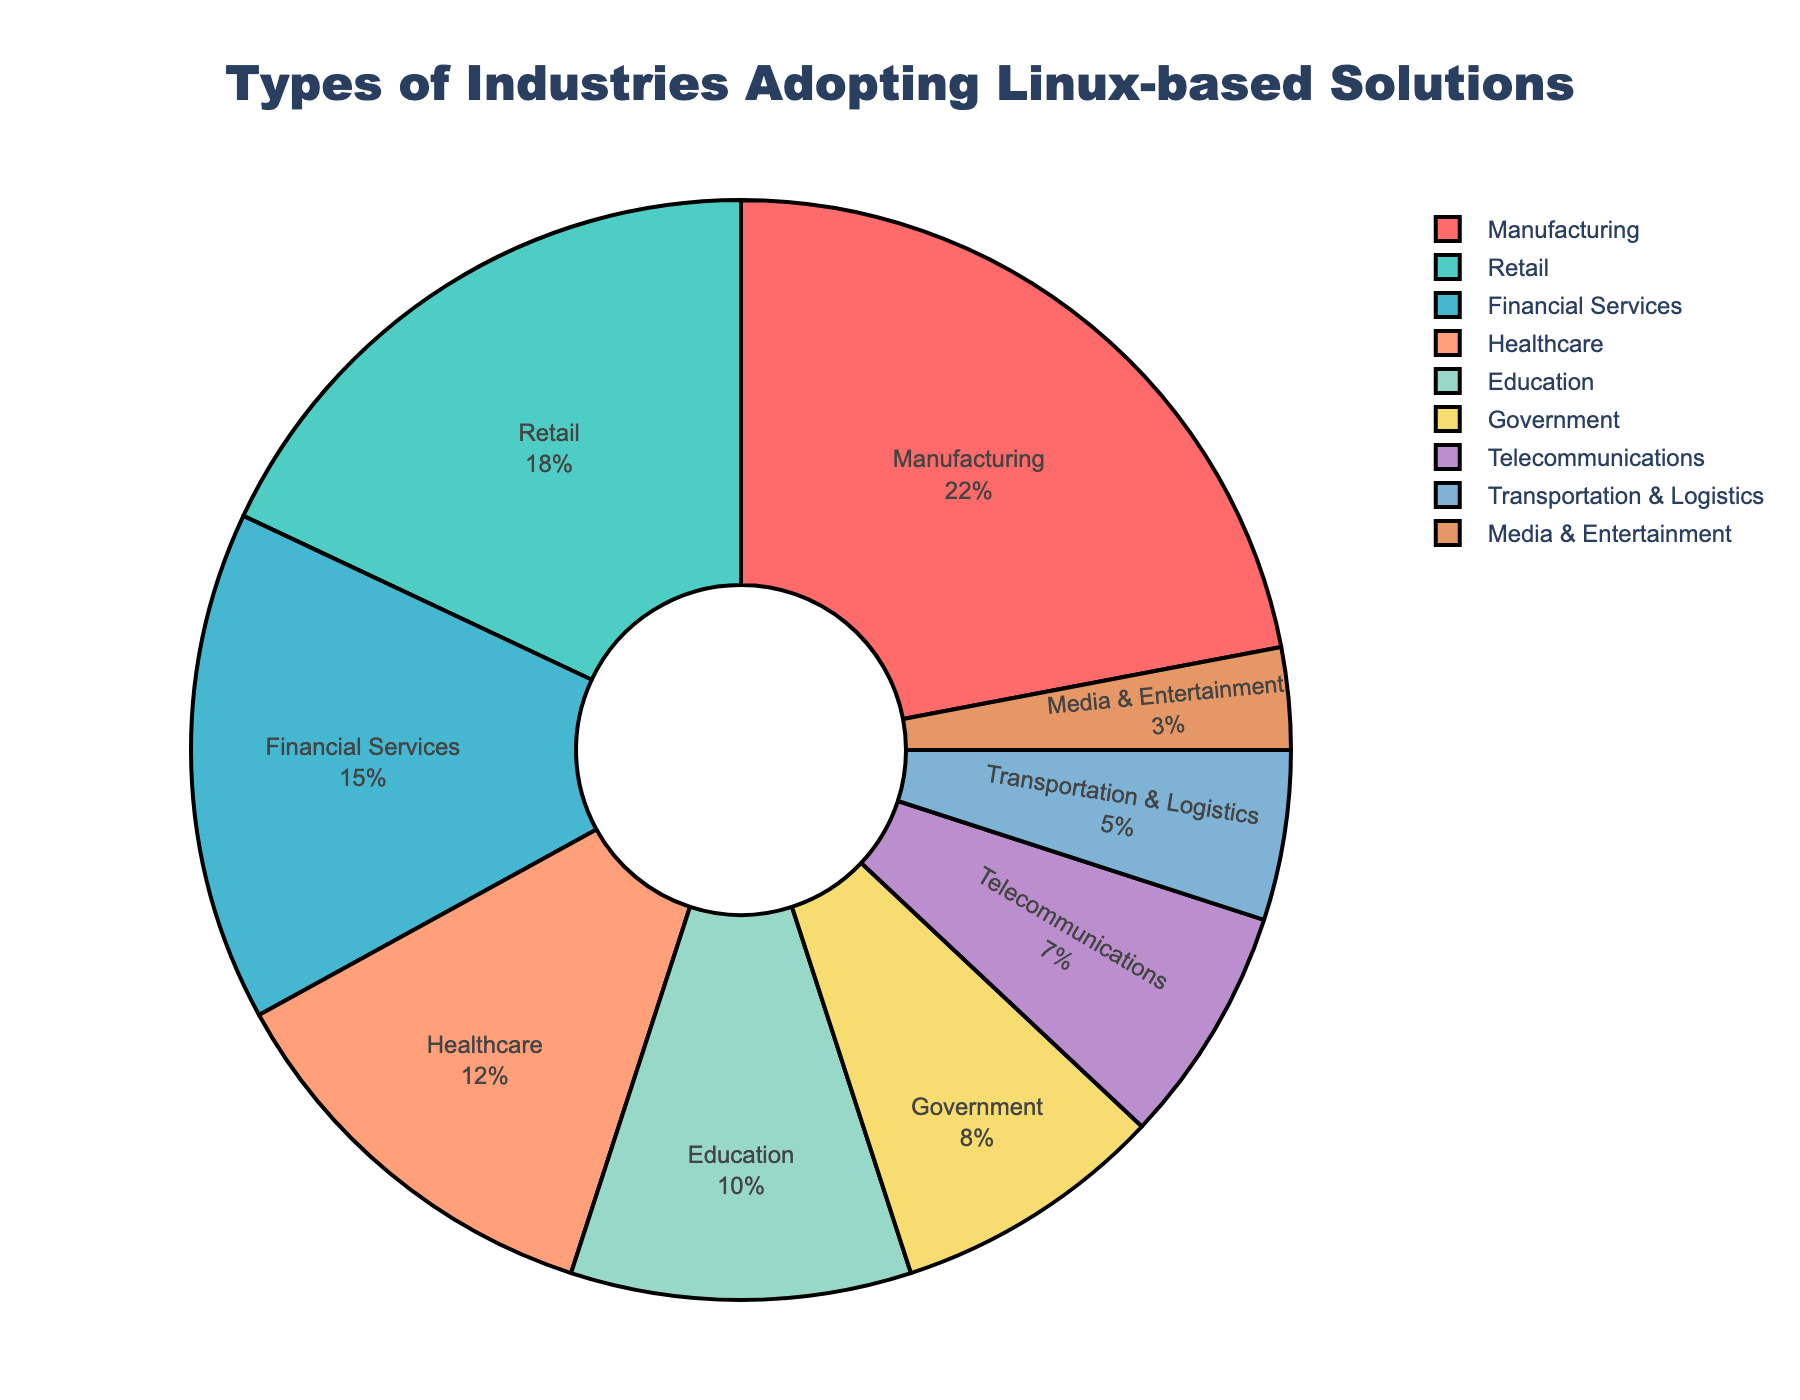What's the highest percentage of industries adopting Linux-based solutions? Look at the pie chart and identify the industry with the largest section and highest percentage value. The largest section and the highest percentage is attributed to Manufacturing, which comprises 22%.
Answer: Manufacturing (22%) Which industry has the smallest adoption rate of Linux-based solutions? Observe the smallest slice of the pie chart and check its corresponding label. The smallest slice is colored in a light brown hue and labeled Media & Entertainment with 3%.
Answer: Media & Entertainment (3%) How much more percentage does the Manufacturing sector have compared to the Telecommunications sector? Note the percentages of both sectors: Manufacturing is 22% and Telecommunications is 7%. Subtract the latter from the former: 22% - 7% = 15%.
Answer: 15% What combined percentage of industries does Manufacturing, Retail, and Financial Services represent? Sum the percentages of Manufacturing (22%), Retail (18%), and Financial Services (15%): 22% + 18% + 15% = 55%.
Answer: 55% Are the combined percentages of Government and Telecommunications greater than the percentage of Healthcare? Government is 8% and Telecommunications is 7%, their combined percentage is 8% + 7% = 15%. Healthcare is 12%, thus 15% is indeed greater than 12%.
Answer: Yes Which two industries have the same coloring but different percentages, if any? Each industry should be checked for unique colors as some can look similar. Based on examination, no two industries share the exact same coloring in this chart.
Answer: None What is the total percentage share of industries with less than 10% adoption rates? List out the industries with less than 10%: Government (8%), Telecommunications (7%), Transportation & Logistics (5%), and Media & Entertainment (3%). Sum the percentages: 8% + 7% + 5% + 3% = 23%.
Answer: 23% What's the difference in percentage between Healthcare and Education sectors? Identify Healthcare is 12% and Education is 10%. Subtract the latter from the former: 12% - 10% = 2%.
Answer: 2% Which color represents the Education sector? Locate the slice labeled as Education and identify its color. Education is represented by a yellow color.
Answer: Yellow Is the percentage of Transportation & Logistics higher than Media & Entertainment? Observe the segments of both: Transportation & Logistics is 5%, while Media & Entertainment is 3%. Since 5% is greater than 3%, the answer is yes.
Answer: Yes 